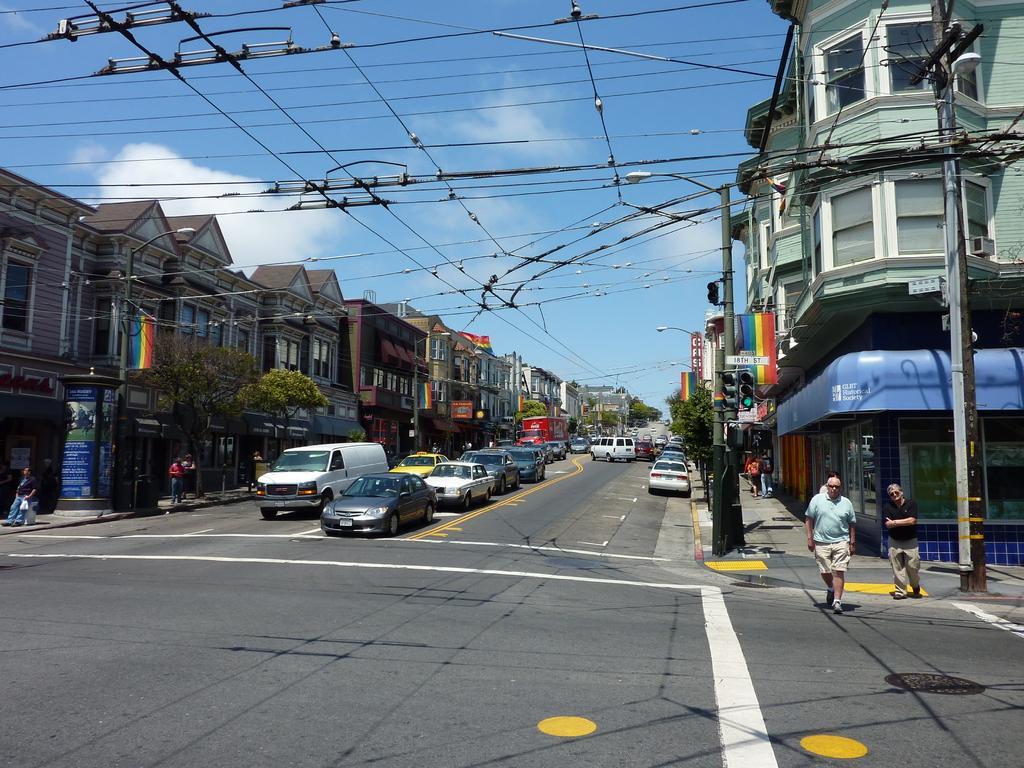In one or two sentences, can you explain what this image depicts? In this picture there is a road. I can observe some cars on the road. On the right side there are two men walking on the road. I can observe some poles and wires. On either sides of the road there are buildings and trees. In the background there are some clouds in the sky. 